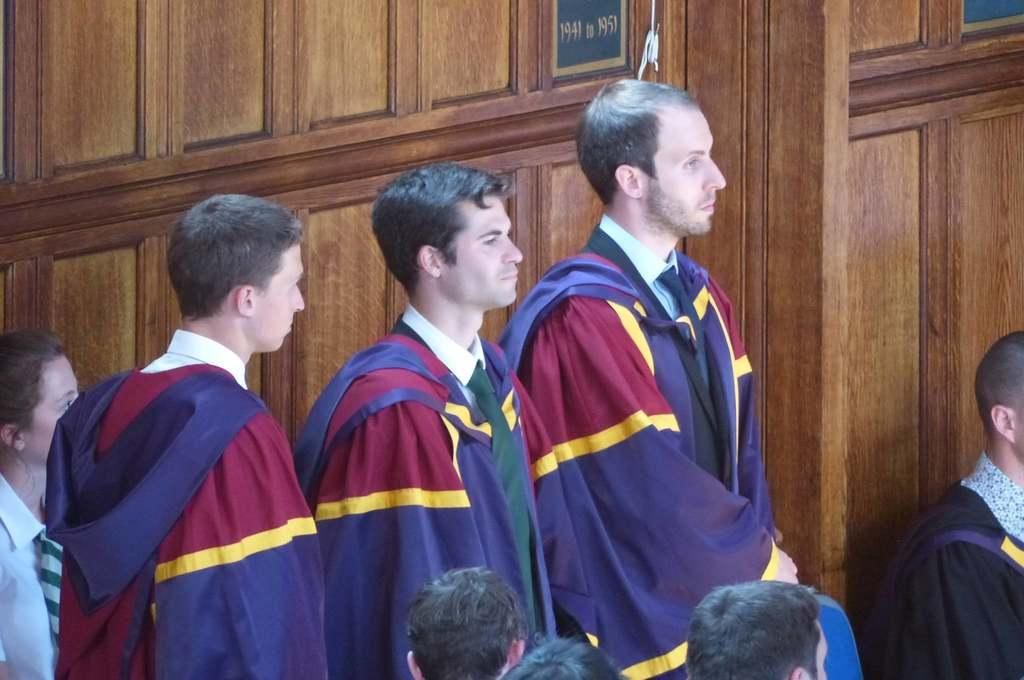What can be seen in the front of the image? There are people in the front of the image. What are some of the people doing in the image? Some people are sitting on chairs. What type of structure is visible in the background of the image? There is a wooden wall in the background of the image. What else can be seen in the background of the image? There are boards in the background of the image. What action is the example of cause and effect in the image? There is no specific action or example of cause and effect present in the image. 